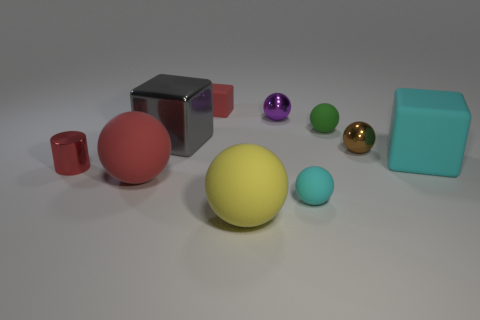What color is the ball that is the same size as the yellow thing?
Keep it short and to the point. Red. Is there a gray metal object that has the same shape as the big red thing?
Offer a very short reply. No. What shape is the small thing that is the same color as the tiny metal cylinder?
Your answer should be very brief. Cube. Is there a large object right of the red rubber thing behind the tiny shiny object that is in front of the large cyan object?
Your response must be concise. Yes. There is a yellow matte object that is the same size as the gray metal cube; what shape is it?
Give a very brief answer. Sphere. What color is the other tiny rubber object that is the same shape as the small cyan thing?
Make the answer very short. Green. How many objects are tiny matte spheres or yellow spheres?
Your answer should be very brief. 3. Do the red thing that is behind the cyan matte cube and the cyan object that is on the right side of the small green matte thing have the same shape?
Keep it short and to the point. Yes. There is a tiny green thing that is behind the small red shiny object; what shape is it?
Make the answer very short. Sphere. Are there an equal number of small red metallic cylinders that are to the right of the yellow matte ball and cyan objects that are on the left side of the tiny brown metallic object?
Keep it short and to the point. No. 